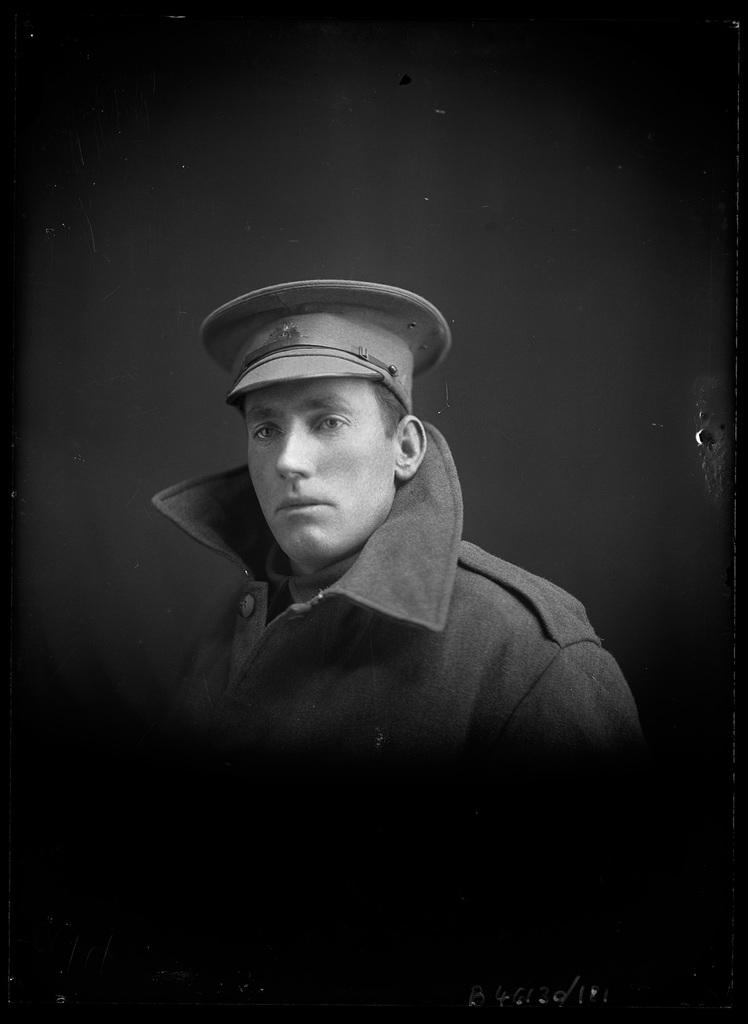What is the color scheme of the image? The image is black and white. Can you describe the main subject of the image? There is a man in the image. How many rings can be seen on the man's fingers in the image? There are no rings visible on the man's fingers in the image, as it is a black and white image and rings may not be distinguishable. 